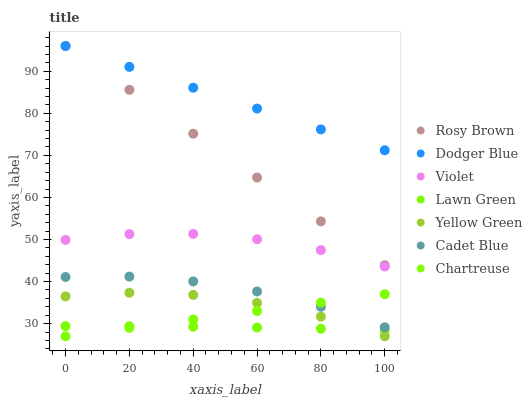Does Lawn Green have the minimum area under the curve?
Answer yes or no. Yes. Does Dodger Blue have the maximum area under the curve?
Answer yes or no. Yes. Does Cadet Blue have the minimum area under the curve?
Answer yes or no. No. Does Cadet Blue have the maximum area under the curve?
Answer yes or no. No. Is Chartreuse the smoothest?
Answer yes or no. Yes. Is Yellow Green the roughest?
Answer yes or no. Yes. Is Cadet Blue the smoothest?
Answer yes or no. No. Is Cadet Blue the roughest?
Answer yes or no. No. Does Chartreuse have the lowest value?
Answer yes or no. Yes. Does Cadet Blue have the lowest value?
Answer yes or no. No. Does Dodger Blue have the highest value?
Answer yes or no. Yes. Does Cadet Blue have the highest value?
Answer yes or no. No. Is Lawn Green less than Cadet Blue?
Answer yes or no. Yes. Is Violet greater than Lawn Green?
Answer yes or no. Yes. Does Lawn Green intersect Chartreuse?
Answer yes or no. Yes. Is Lawn Green less than Chartreuse?
Answer yes or no. No. Is Lawn Green greater than Chartreuse?
Answer yes or no. No. Does Lawn Green intersect Cadet Blue?
Answer yes or no. No. 